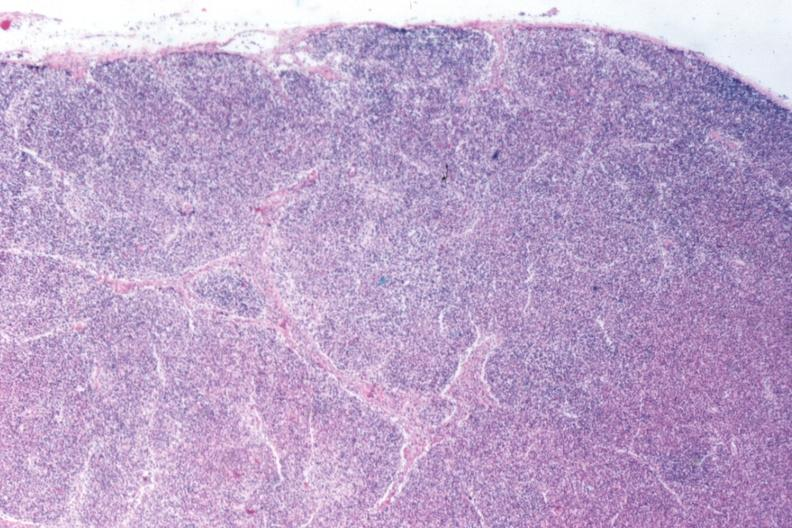does multiple myeloma show that total effacement case appears to have changed into a blast crisis?
Answer the question using a single word or phrase. No 